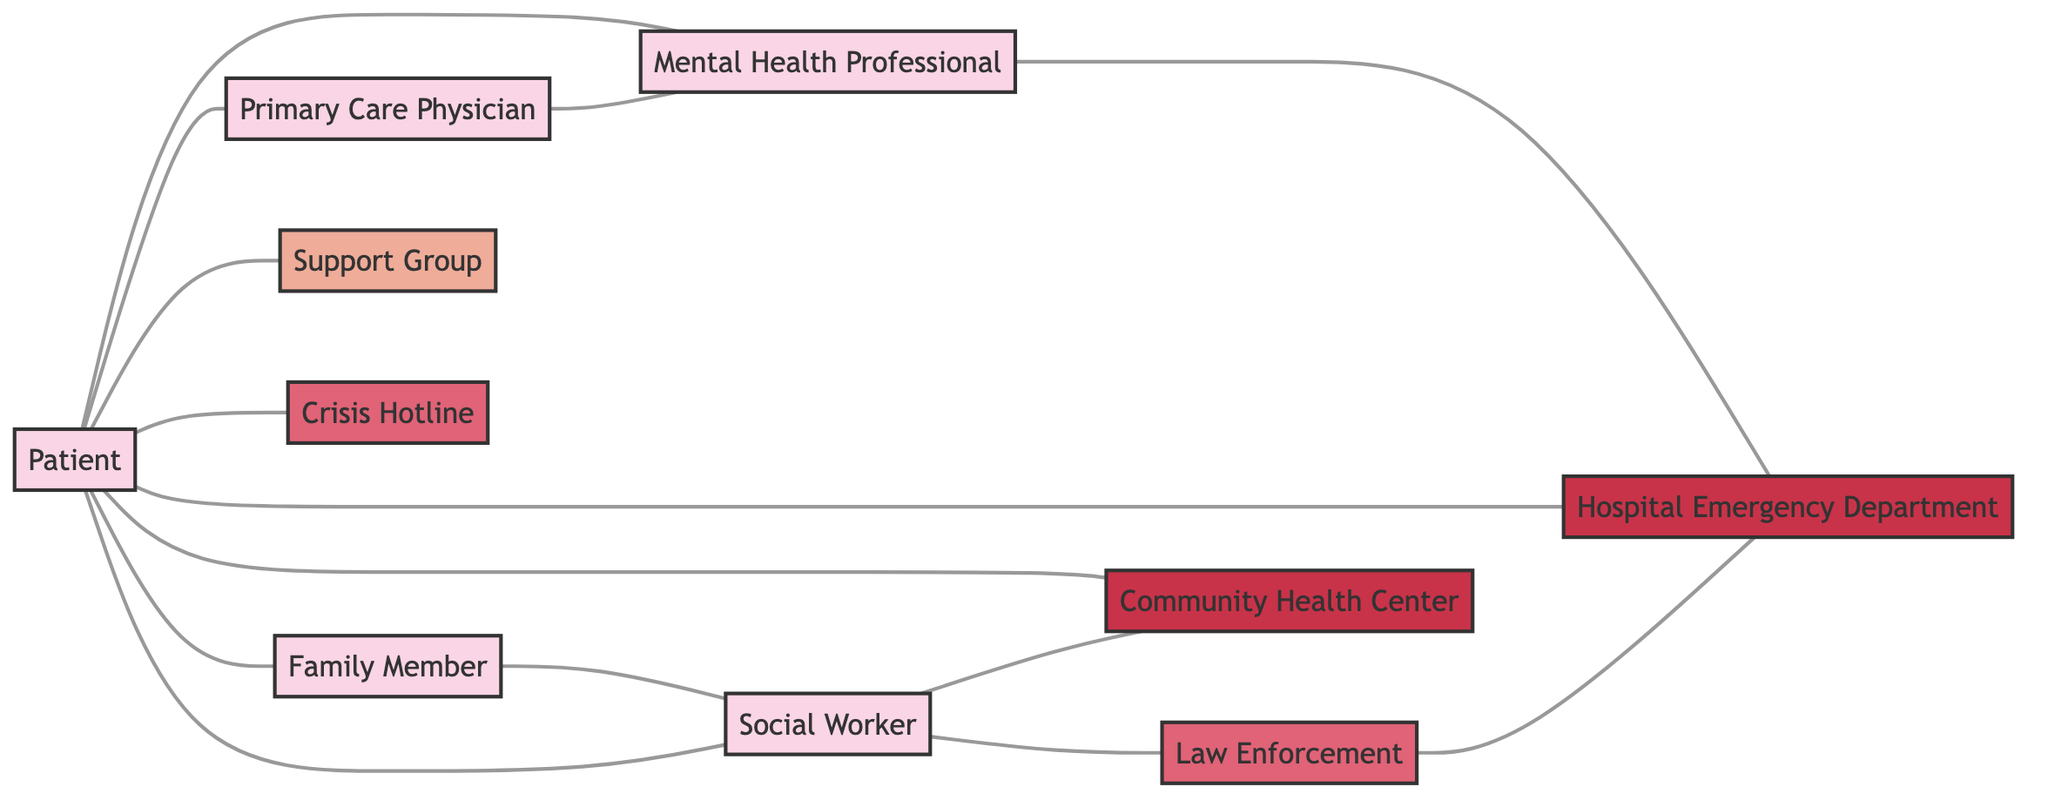What is the total number of nodes in the diagram? The diagram includes the following nodes: Mental Health Professional, Patient, Primary Care Physician, Support Group, Crisis Hotline, Hospital Emergency Department, Community Health Center, Social Worker, Family Member, and Law Enforcement. Counting these gives a total of 10 nodes.
Answer: 10 What relationship does a Patient have with a Support Group? The diagram indicates that a Patient "participates in" the Support Group, representing an engagement or involvement in the group for mental health support.
Answer: participates in How many edges connect the Patient to different services or professionals? The Patient connects to the following nodes: Mental Health Professional, Primary Care Physician, Support Group, Crisis Hotline, Hospital Emergency Department, Community Health Center, and Family Member. This totals to 7 edges connecting the Patient to different services or professionals.
Answer: 7 Which service does a Social Worker coordinate with for crisis intervention? The diagram clearly shows that a Social Worker coordinates with Law Enforcement for crisis intervention, indicating a collaborative relationship during emergencies.
Answer: Law Enforcement What do Family Members contact a Social Worker for? The diagram specifies that Family Members contact Social Workers for resources, indicating that they seek help in connecting with necessary support mechanisms for the Patient.
Answer: resources What is the direct relationship between a Mental Health Professional and a Hospital Emergency Department? The diagram shows a connection indicating that a Mental Health Professional "coordinates with" the Hospital Emergency Department, which implies active collaboration regarding the Patient's care.
Answer: coordinates with Which node has the highest number of edges connected to it? By examining the relationships, the Patient node has connections to seven other nodes, making it the node with the highest number of edges in this undirected graph.
Answer: Patient How does a Primary Care Physician relate to a Mental Health Professional? The flow of the diagram indicates that the Primary Care Physician "refers to" the Mental Health Professional, showing their role in directing patients to mental health specialists as needed.
Answer: refers to Which facility provides immediate care and has a relationship with Law Enforcement? The diagram shows that the Hospital Emergency Department has a connection with Law Enforcement, indicating that it is involved in providing immediate care during emergencies and facilitating patient transfers.
Answer: Hospital Emergency Department 